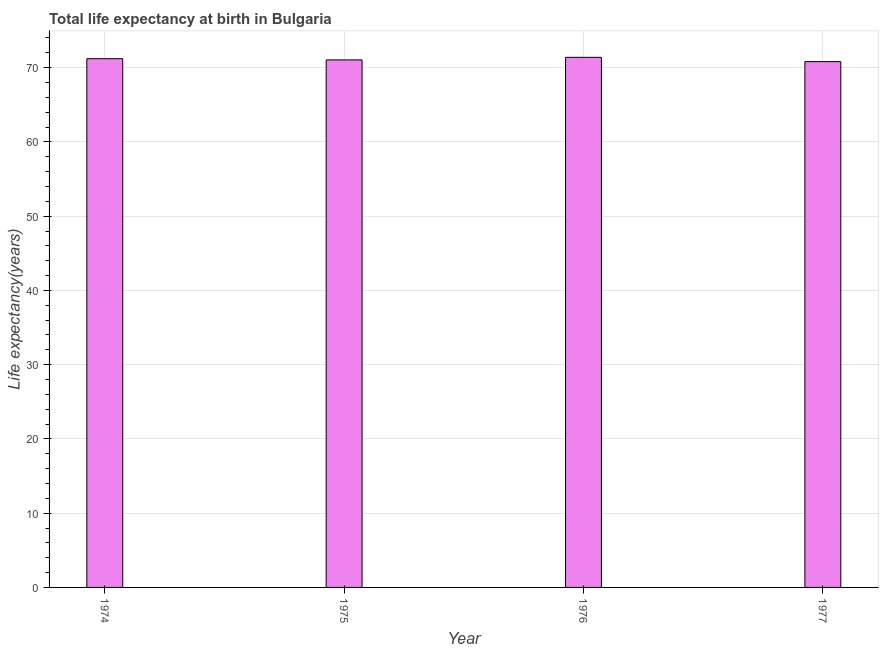Does the graph contain any zero values?
Provide a succinct answer. No. Does the graph contain grids?
Keep it short and to the point. Yes. What is the title of the graph?
Provide a short and direct response. Total life expectancy at birth in Bulgaria. What is the label or title of the X-axis?
Keep it short and to the point. Year. What is the label or title of the Y-axis?
Your answer should be compact. Life expectancy(years). What is the life expectancy at birth in 1977?
Offer a terse response. 70.82. Across all years, what is the maximum life expectancy at birth?
Make the answer very short. 71.39. Across all years, what is the minimum life expectancy at birth?
Give a very brief answer. 70.82. In which year was the life expectancy at birth maximum?
Your answer should be compact. 1976. What is the sum of the life expectancy at birth?
Offer a terse response. 284.47. What is the difference between the life expectancy at birth in 1975 and 1976?
Ensure brevity in your answer.  -0.34. What is the average life expectancy at birth per year?
Keep it short and to the point. 71.12. What is the median life expectancy at birth?
Give a very brief answer. 71.13. What is the ratio of the life expectancy at birth in 1976 to that in 1977?
Your response must be concise. 1.01. What is the difference between the highest and the second highest life expectancy at birth?
Make the answer very short. 0.19. What is the difference between the highest and the lowest life expectancy at birth?
Give a very brief answer. 0.58. How many bars are there?
Make the answer very short. 4. How many years are there in the graph?
Offer a terse response. 4. What is the Life expectancy(years) in 1974?
Offer a terse response. 71.21. What is the Life expectancy(years) of 1975?
Your answer should be very brief. 71.05. What is the Life expectancy(years) of 1976?
Provide a succinct answer. 71.39. What is the Life expectancy(years) of 1977?
Your answer should be compact. 70.82. What is the difference between the Life expectancy(years) in 1974 and 1975?
Your answer should be compact. 0.16. What is the difference between the Life expectancy(years) in 1974 and 1976?
Your answer should be compact. -0.19. What is the difference between the Life expectancy(years) in 1974 and 1977?
Give a very brief answer. 0.39. What is the difference between the Life expectancy(years) in 1975 and 1976?
Your answer should be compact. -0.35. What is the difference between the Life expectancy(years) in 1975 and 1977?
Make the answer very short. 0.23. What is the difference between the Life expectancy(years) in 1976 and 1977?
Your answer should be compact. 0.58. What is the ratio of the Life expectancy(years) in 1974 to that in 1976?
Your answer should be compact. 1. What is the ratio of the Life expectancy(years) in 1974 to that in 1977?
Make the answer very short. 1.01. What is the ratio of the Life expectancy(years) in 1976 to that in 1977?
Offer a very short reply. 1.01. 